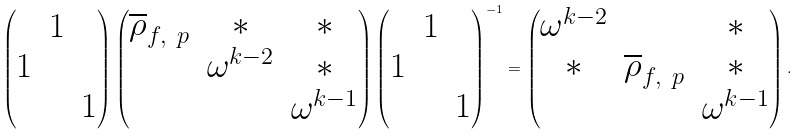<formula> <loc_0><loc_0><loc_500><loc_500>\begin{pmatrix} & 1 & \\ 1 & & \\ & & 1 \end{pmatrix} \begin{pmatrix} \overline { \rho } _ { f , \ p } & * & * \\ & \omega ^ { k - 2 } & * \\ & & \omega ^ { k - 1 } \end{pmatrix} \begin{pmatrix} & 1 & \\ 1 & & \\ & & 1 \end{pmatrix} ^ { - 1 } = \begin{pmatrix} \omega ^ { k - 2 } & & * \\ * & \overline { \rho } _ { f , \ p } & * \\ & & \omega ^ { k - 1 } \end{pmatrix} .</formula> 